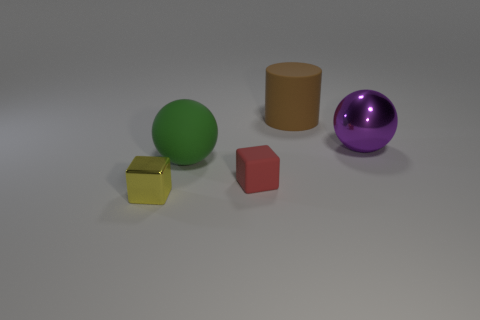Subtract all purple cubes. Subtract all blue cylinders. How many cubes are left? 2 Add 1 gray rubber things. How many objects exist? 6 Subtract all cubes. How many objects are left? 3 Subtract 0 red balls. How many objects are left? 5 Subtract all large yellow metallic objects. Subtract all large purple metallic balls. How many objects are left? 4 Add 5 big shiny balls. How many big shiny balls are left? 6 Add 2 red things. How many red things exist? 3 